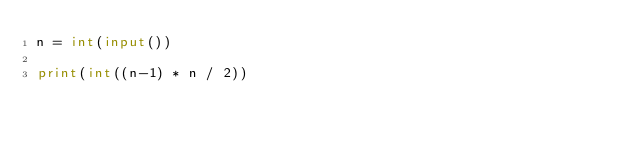Convert code to text. <code><loc_0><loc_0><loc_500><loc_500><_Python_>n = int(input())
 
print(int((n-1) * n / 2))</code> 